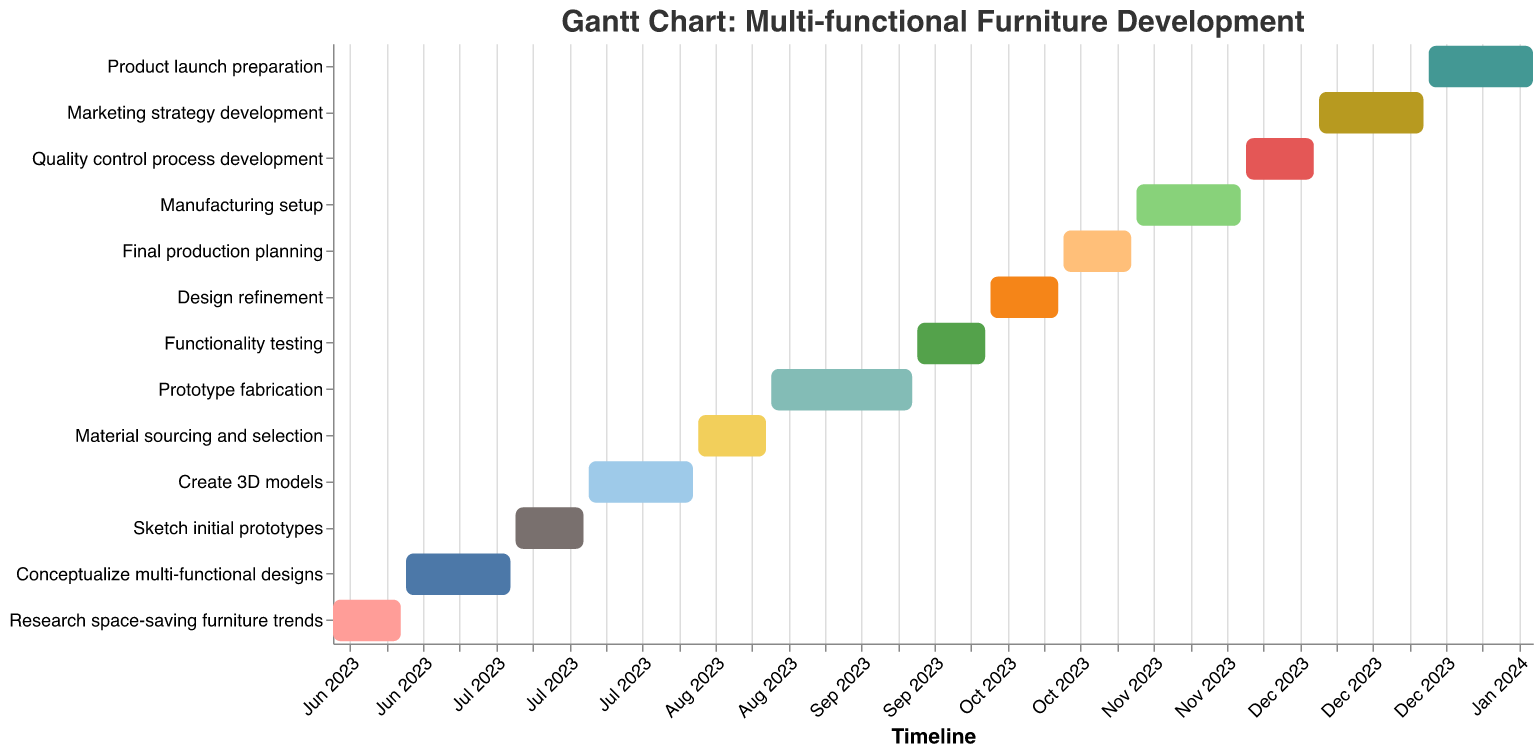What is the title of the Gantt Chart? The title is usually found at the top of the chart, indicating the main subject or focus. In this case, it is likely positioned at the top center of the chart.
Answer: Gantt Chart: Multi-functional Furniture Development When does the "Conceptualize multi-functional designs" task start and end? By locating the respective task on the Y-axis and looking at the corresponding start and end dates on the X-axis, you can determine the timeframe.
Answer: 2023-06-15 to 2023-07-05 Which task has the shortest duration? To identify this, check the "Duration (Days)" tooltip of each task and find the minimum value.
Answer: Research space-saving furniture trends, Sketch initial prototypes, Material sourcing and selection, Functionality testing, Design refinement, Final production planning, Quality control process development (all 14 days) How long does the "Prototype fabrication" task take? Refer to the "Duration (Days)" tooltip of the specified task to find the exact number of days.
Answer: 28 days What are the start and end dates of the "Product launch preparation" task? By locating the specified task on the Y-axis and the corresponding dates on the X-axis, you can determine the timeframe.
Answer: 2023-12-28 to 2024-01-17 Which task ends just before "Design refinement" starts? Identify the end date of the task just preceding "Design refinement" by looking at the dates on the X-axis and comparing tasks.
Answer: Functionality testing How many tasks are scheduled to be completed by the end of September 2023? Count all tasks whose end dates fall in or before September 2023 by checking each task’s "End Date" tooltip.
Answer: 6 tasks (Research space-saving furniture trends, Conceptualize multi-functional designs, Sketch initial prototypes, Create 3D models, Material sourcing and selection, Prototype fabrication) Which tasks overlap with "Functionality testing"? Tasks that have start or end dates between 2023-09-21 and 2023-10-04 will overlap. Check the "Start Date" and "End Date" tooltips to identify them.
Answer: Prototype fabrication, Design refinement What is the average duration of all tasks? Sum up the durations of all tasks and then divide by the number of tasks to find the average. The durations are 14, 21, 14, 21, 14, 28, 14, 14, 14, 21, 14, 21, 21, so the sum is 240 days. There are 13 tasks. Average duration is 240/13.
Answer: Approximately 18.46 days 